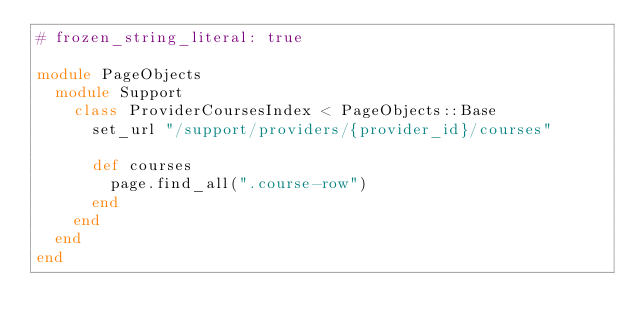Convert code to text. <code><loc_0><loc_0><loc_500><loc_500><_Ruby_># frozen_string_literal: true

module PageObjects
  module Support
    class ProviderCoursesIndex < PageObjects::Base
      set_url "/support/providers/{provider_id}/courses"

      def courses
        page.find_all(".course-row")
      end
    end
  end
end
</code> 